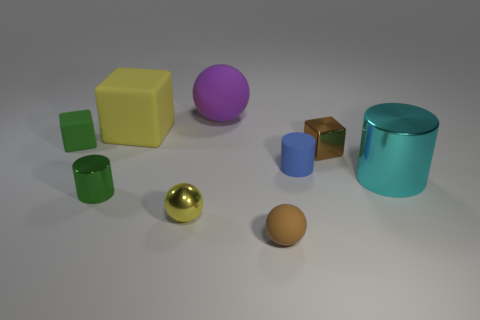Subtract 1 cubes. How many cubes are left? 2 Subtract all brown balls. How many brown cylinders are left? 0 Subtract all tiny red shiny cubes. Subtract all large cyan metallic things. How many objects are left? 8 Add 9 large cyan cylinders. How many large cyan cylinders are left? 10 Add 9 small blue things. How many small blue things exist? 10 Subtract all cyan cylinders. How many cylinders are left? 2 Subtract all small brown spheres. How many spheres are left? 2 Subtract 1 cyan cylinders. How many objects are left? 8 Subtract all balls. How many objects are left? 6 Subtract all gray cubes. Subtract all blue spheres. How many cubes are left? 3 